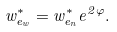Convert formula to latex. <formula><loc_0><loc_0><loc_500><loc_500>w _ { e _ { w } } ^ { * } = w _ { e _ { n } } ^ { * } e ^ { 2 \varphi } .</formula> 